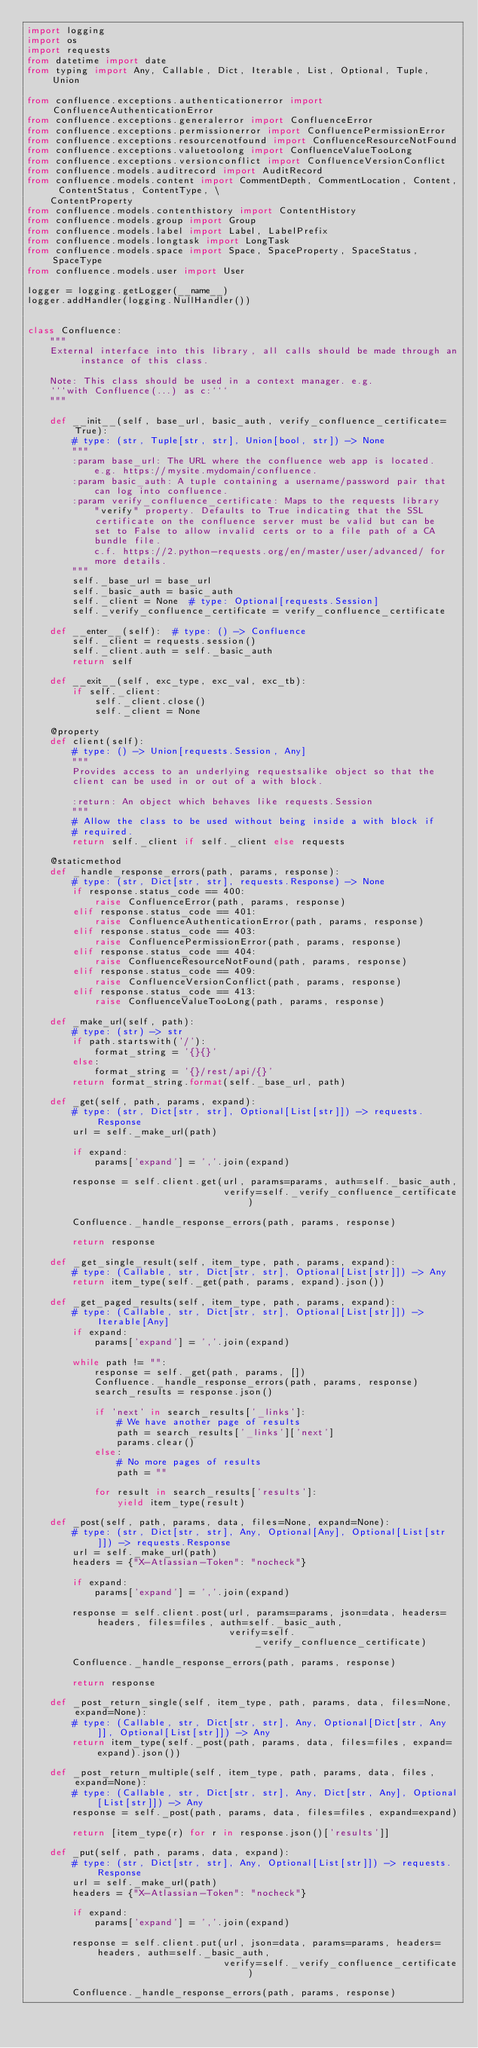<code> <loc_0><loc_0><loc_500><loc_500><_Python_>import logging
import os
import requests
from datetime import date
from typing import Any, Callable, Dict, Iterable, List, Optional, Tuple, Union

from confluence.exceptions.authenticationerror import ConfluenceAuthenticationError
from confluence.exceptions.generalerror import ConfluenceError
from confluence.exceptions.permissionerror import ConfluencePermissionError
from confluence.exceptions.resourcenotfound import ConfluenceResourceNotFound
from confluence.exceptions.valuetoolong import ConfluenceValueTooLong
from confluence.exceptions.versionconflict import ConfluenceVersionConflict
from confluence.models.auditrecord import AuditRecord
from confluence.models.content import CommentDepth, CommentLocation, Content, ContentStatus, ContentType, \
    ContentProperty
from confluence.models.contenthistory import ContentHistory
from confluence.models.group import Group
from confluence.models.label import Label, LabelPrefix
from confluence.models.longtask import LongTask
from confluence.models.space import Space, SpaceProperty, SpaceStatus, SpaceType
from confluence.models.user import User

logger = logging.getLogger(__name__)
logger.addHandler(logging.NullHandler())


class Confluence:
    """
    External interface into this library, all calls should be made through an instance of this class.

    Note: This class should be used in a context manager. e.g.
    ```with Confluence(...) as c:```
    """

    def __init__(self, base_url, basic_auth, verify_confluence_certificate=True):
        # type: (str, Tuple[str, str], Union[bool, str]) -> None
        """
        :param base_url: The URL where the confluence web app is located.
            e.g. https://mysite.mydomain/confluence.
        :param basic_auth: A tuple containing a username/password pair that
            can log into confluence.
        :param verify_confluence_certificate: Maps to the requests library
            "verify" property. Defaults to True indicating that the SSL
            certificate on the confluence server must be valid but can be
            set to False to allow invalid certs or to a file path of a CA
            bundle file.
            c.f. https://2.python-requests.org/en/master/user/advanced/ for
            more details.
        """
        self._base_url = base_url
        self._basic_auth = basic_auth
        self._client = None  # type: Optional[requests.Session]
        self._verify_confluence_certificate = verify_confluence_certificate

    def __enter__(self):  # type: () -> Confluence
        self._client = requests.session()
        self._client.auth = self._basic_auth
        return self

    def __exit__(self, exc_type, exc_val, exc_tb):
        if self._client:
            self._client.close()
            self._client = None

    @property
    def client(self):
        # type: () -> Union[requests.Session, Any]
        """
        Provides access to an underlying requestsalike object so that the
        client can be used in or out of a with block.

        :return: An object which behaves like requests.Session
        """
        # Allow the class to be used without being inside a with block if
        # required.
        return self._client if self._client else requests

    @staticmethod
    def _handle_response_errors(path, params, response):
        # type: (str, Dict[str, str], requests.Response) -> None
        if response.status_code == 400:
            raise ConfluenceError(path, params, response)
        elif response.status_code == 401:
            raise ConfluenceAuthenticationError(path, params, response)
        elif response.status_code == 403:
            raise ConfluencePermissionError(path, params, response)
        elif response.status_code == 404:
            raise ConfluenceResourceNotFound(path, params, response)
        elif response.status_code == 409:
            raise ConfluenceVersionConflict(path, params, response)
        elif response.status_code == 413:
            raise ConfluenceValueTooLong(path, params, response)

    def _make_url(self, path):
        # type: (str) -> str
        if path.startswith('/'):
            format_string = '{}{}'
        else:
            format_string = '{}/rest/api/{}'
        return format_string.format(self._base_url, path)

    def _get(self, path, params, expand):
        # type: (str, Dict[str, str], Optional[List[str]]) -> requests.Response
        url = self._make_url(path)

        if expand:
            params['expand'] = ','.join(expand)

        response = self.client.get(url, params=params, auth=self._basic_auth,
                                   verify=self._verify_confluence_certificate)

        Confluence._handle_response_errors(path, params, response)

        return response

    def _get_single_result(self, item_type, path, params, expand):
        # type: (Callable, str, Dict[str, str], Optional[List[str]]) -> Any
        return item_type(self._get(path, params, expand).json())

    def _get_paged_results(self, item_type, path, params, expand):
        # type: (Callable, str, Dict[str, str], Optional[List[str]]) -> Iterable[Any]
        if expand:
            params['expand'] = ','.join(expand)

        while path != "":
            response = self._get(path, params, [])
            Confluence._handle_response_errors(path, params, response)
            search_results = response.json()

            if 'next' in search_results['_links']:
                # We have another page of results
                path = search_results['_links']['next']
                params.clear()
            else:
                # No more pages of results
                path = ""

            for result in search_results['results']:
                yield item_type(result)

    def _post(self, path, params, data, files=None, expand=None):
        # type: (str, Dict[str, str], Any, Optional[Any], Optional[List[str]]) -> requests.Response
        url = self._make_url(path)
        headers = {"X-Atlassian-Token": "nocheck"}

        if expand:
            params['expand'] = ','.join(expand)

        response = self.client.post(url, params=params, json=data, headers=headers, files=files, auth=self._basic_auth,
                                    verify=self._verify_confluence_certificate)

        Confluence._handle_response_errors(path, params, response)

        return response

    def _post_return_single(self, item_type, path, params, data, files=None, expand=None):
        # type: (Callable, str, Dict[str, str], Any, Optional[Dict[str, Any]], Optional[List[str]]) -> Any
        return item_type(self._post(path, params, data, files=files, expand=expand).json())

    def _post_return_multiple(self, item_type, path, params, data, files, expand=None):
        # type: (Callable, str, Dict[str, str], Any, Dict[str, Any], Optional[List[str]]) -> Any
        response = self._post(path, params, data, files=files, expand=expand)

        return [item_type(r) for r in response.json()['results']]

    def _put(self, path, params, data, expand):
        # type: (str, Dict[str, str], Any, Optional[List[str]]) -> requests.Response
        url = self._make_url(path)
        headers = {"X-Atlassian-Token": "nocheck"}

        if expand:
            params['expand'] = ','.join(expand)

        response = self.client.put(url, json=data, params=params, headers=headers, auth=self._basic_auth,
                                   verify=self._verify_confluence_certificate)

        Confluence._handle_response_errors(path, params, response)
</code> 